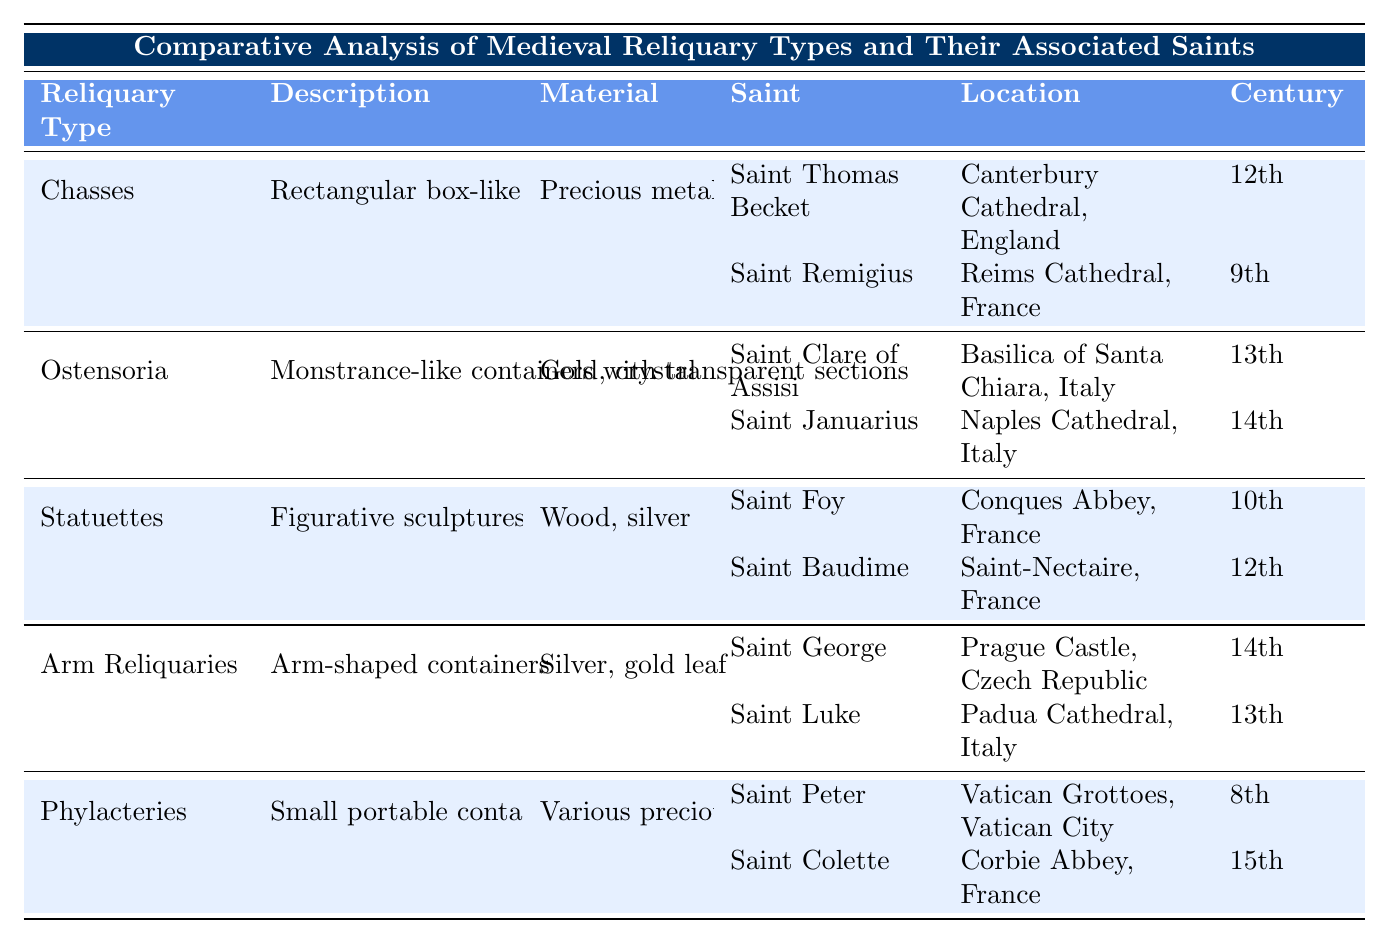What are the materials used in the construction of Arm Reliquaries? The table lists the materials for each type of reliquary. For Arm Reliquaries, it indicates that the materials are Silver and gold leaf.
Answer: Silver, gold leaf Which saint is associated with the 8th-century reliquary type? According to the table, only Phylacteries has a saint associated with the 8th century, which is Saint Peter.
Answer: Saint Peter How many types of reliquaries contain saints associated with Italy? The table shows that Ostensoria, Arm Reliquaries, and Phylacteries have saints associated with Italy, specifically Saint Clare of Assisi, Saint Luke, and Saint Colette, respectively—totaling three types.
Answer: Three Is there any reliquary type associated with a saint from the 14th century? The table includes saints from various centuries; both Saint Januarius (Ostensoria) and Saint George (Arm Reliquaries) are associated with the 14th century. Thus, yes, there is a reliquary type associated with a 14th-century saint.
Answer: Yes Which reliquary type has saints from both the 9th and 12th centuries? Chasses contains both Saint Remigius from the 9th century and Saint Thomas Becket from the 12th century as associated saints.
Answer: Chasses How many total saints are associated with the Statuettes type? The Statuettes type lists two saints: Saint Foy and Saint Baudime.
Answer: Two What is the earliest century represented in the table? By examining the centuries provided, Saint Peter is associated with the 8th century, making it the earliest century represented.
Answer: 8th century Which type of reliquary has the most recent associated saint? Looking at the table, Phylacteries has Saint Colette, associated with the 15th century, making this the most recent.
Answer: Phylacteries 